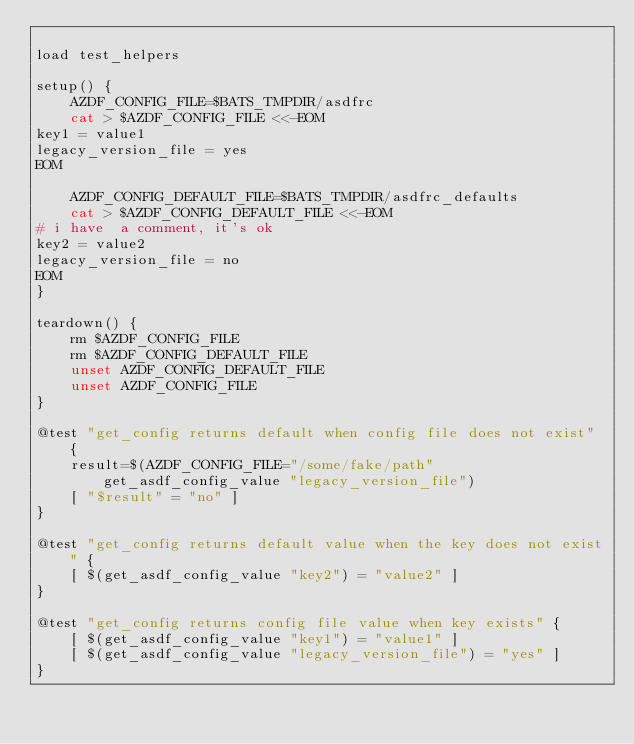Convert code to text. <code><loc_0><loc_0><loc_500><loc_500><_Bash_>
load test_helpers

setup() {
    AZDF_CONFIG_FILE=$BATS_TMPDIR/asdfrc
    cat > $AZDF_CONFIG_FILE <<-EOM
key1 = value1
legacy_version_file = yes
EOM

    AZDF_CONFIG_DEFAULT_FILE=$BATS_TMPDIR/asdfrc_defaults
    cat > $AZDF_CONFIG_DEFAULT_FILE <<-EOM
# i have  a comment, it's ok
key2 = value2
legacy_version_file = no
EOM
}

teardown() {
    rm $AZDF_CONFIG_FILE
    rm $AZDF_CONFIG_DEFAULT_FILE
    unset AZDF_CONFIG_DEFAULT_FILE
    unset AZDF_CONFIG_FILE
}

@test "get_config returns default when config file does not exist" {
    result=$(AZDF_CONFIG_FILE="/some/fake/path" get_asdf_config_value "legacy_version_file")
    [ "$result" = "no" ]
}

@test "get_config returns default value when the key does not exist" {
    [ $(get_asdf_config_value "key2") = "value2" ]
}

@test "get_config returns config file value when key exists" {
    [ $(get_asdf_config_value "key1") = "value1" ]
    [ $(get_asdf_config_value "legacy_version_file") = "yes" ]
}
</code> 